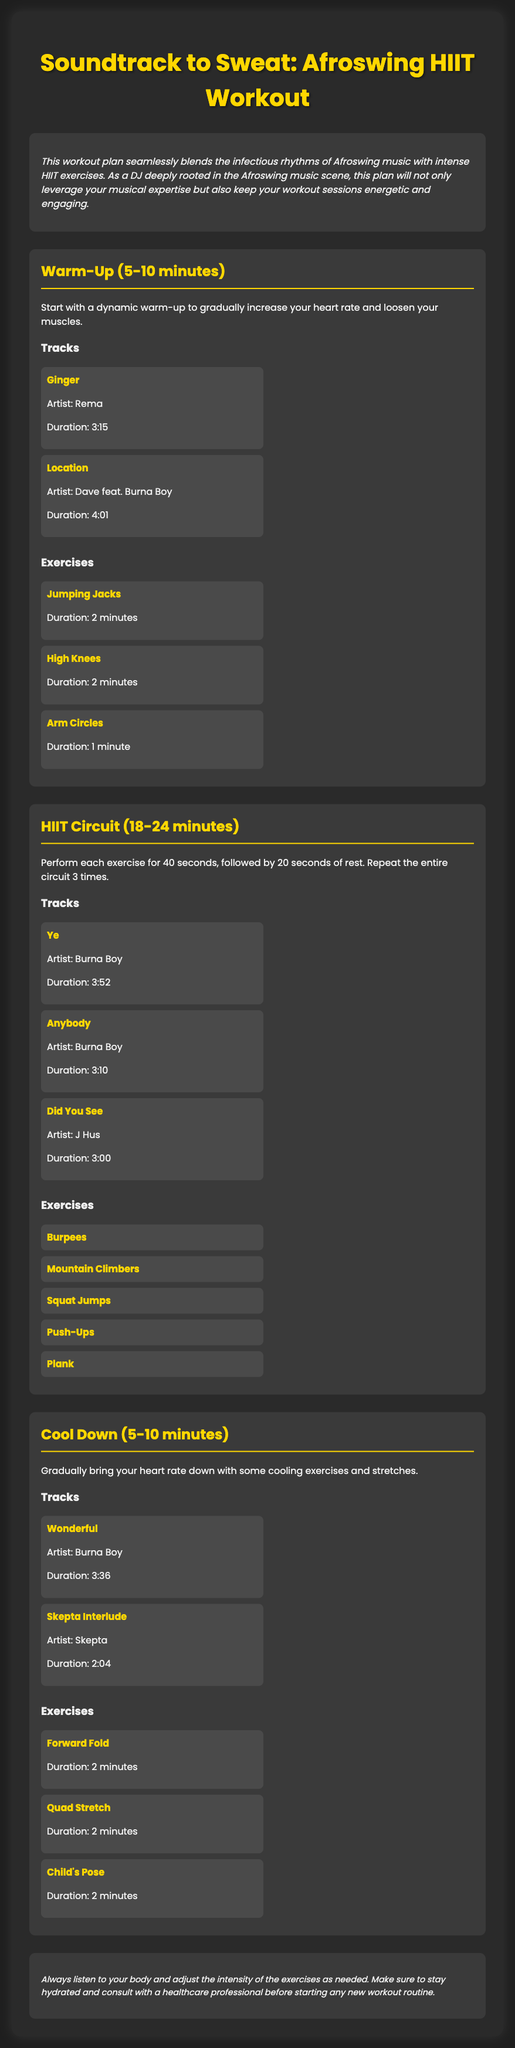what is the title of the workout plan? The title is stated at the top of the document in a large font.
Answer: Soundtrack to Sweat: Afroswing HIIT Workout how long is the warm-up section? The duration for the warm-up is mentioned in the heading of the section.
Answer: 5-10 minutes who is the artist of the track "Ginger"? The document provides the artist information directly below the track title.
Answer: Rema what exercises are included in the HIIT Circuit? The exercises listed under the HIIT Circuit section provide this information.
Answer: Burpees, Mountain Climbers, Squat Jumps, Push-Ups, Plank what is the duration of the track "Wonderful"? The duration is mentioned right below the track title in the cooldown section.
Answer: 3:36 how many times should the HIIT circuit be repeated? This is specified in the instructions for the HIIT circuit.
Answer: 3 times which exercise lasts for 2 minutes during the cool down? The document lists exercises and their durations in the cool down section.
Answer: Forward Fold, Quad Stretch, Child's Pose what type of music is integrated into this workout plan? The overview specifies the style of music that accompanies the workout.
Answer: Afroswing what is the main purpose of the document? This can be inferred from the overview provided at the beginning.
Answer: Integrating Afroswing Beats into HIIT Sessions 